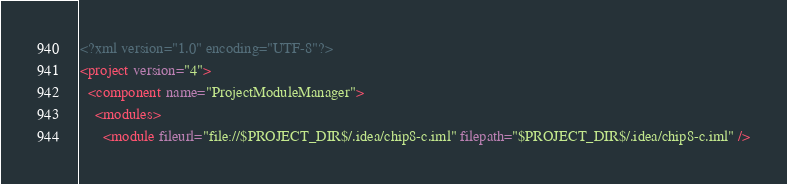Convert code to text. <code><loc_0><loc_0><loc_500><loc_500><_XML_><?xml version="1.0" encoding="UTF-8"?>
<project version="4">
  <component name="ProjectModuleManager">
    <modules>
      <module fileurl="file://$PROJECT_DIR$/.idea/chip8-c.iml" filepath="$PROJECT_DIR$/.idea/chip8-c.iml" /></code> 